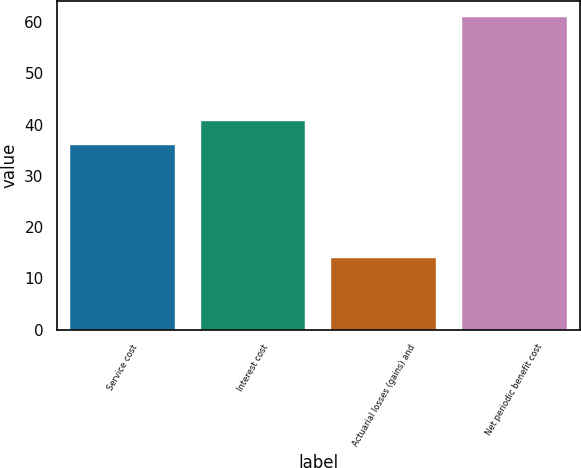Convert chart. <chart><loc_0><loc_0><loc_500><loc_500><bar_chart><fcel>Service cost<fcel>Interest cost<fcel>Actuarial losses (gains) and<fcel>Net periodic benefit cost<nl><fcel>36<fcel>40.7<fcel>14<fcel>61<nl></chart> 